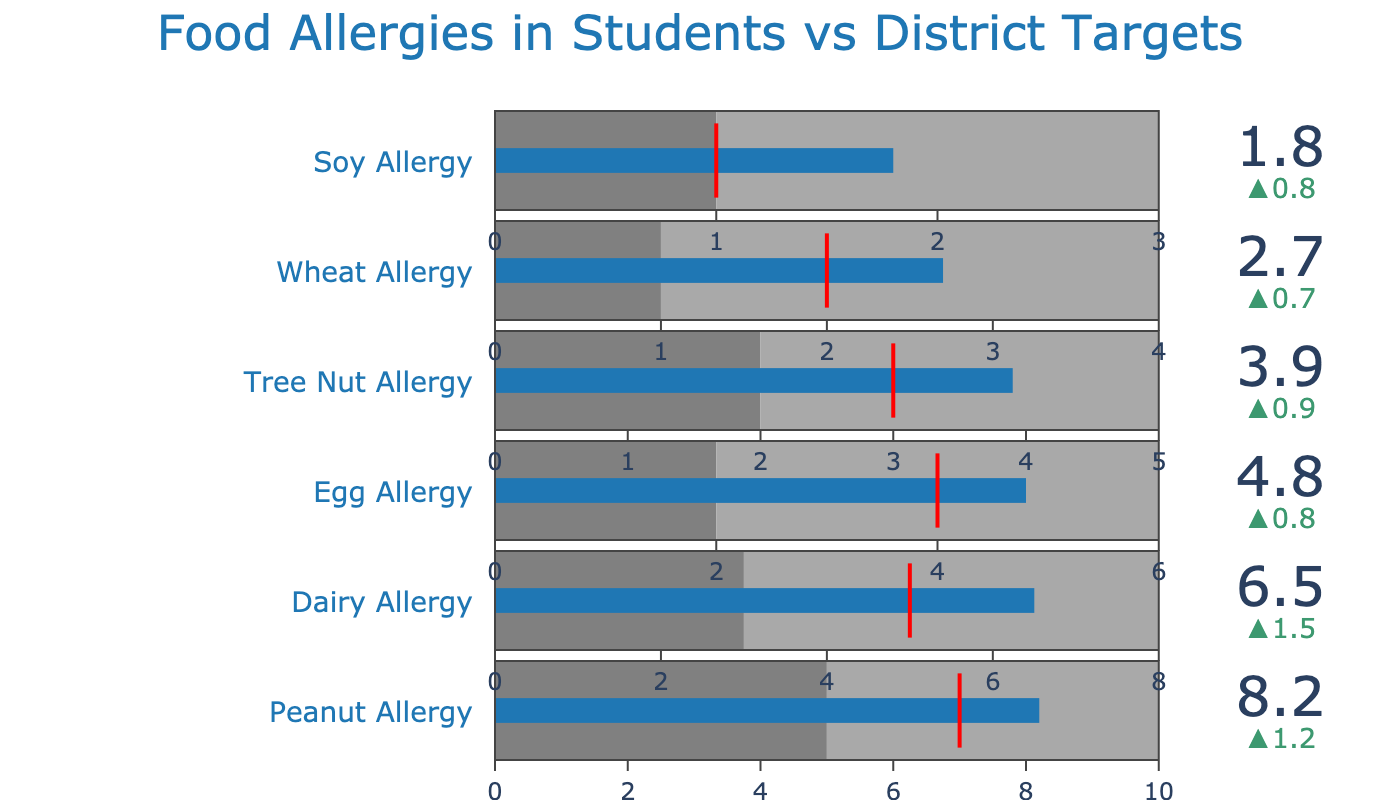What's the actual percentage of students with peanut allergies? The figure displays a bullet chart with the actual percentage, delta, and targets for different food allergies. For peanut allergies, the actual percentage is displayed as 8.2%.
Answer: 8.2% What is the school district target for dairy allergies? The bullet chart specifies targets for various food allergies, and for dairy allergies, the target percentage is indicated as 5%.
Answer: 5% Which food allergy has the largest actual percentage value? By comparing the values displayed on the bullet chart, we can see that the peanut allergy has the largest actual percentage value, which is 8.2%.
Answer: Peanut Allergy How much does the actual percentage of soy allergies differ from the target percentage? The bullet chart shows that the actual percentage for soy allergies is 1.8% and the target is 1%. The difference can be calculated by subtracting the target percentage from the actual percentage: 1.8% - 1% = 0.8%.
Answer: 0.8% Are the actual values for tree nut and egg allergies above or below their respective targets? By inspecting the bullet chart, it is seen that the actual values for both tree nut (3.9% vs. 3%) and egg allergies (4.8% vs. 4%) exceed their respective targets.
Answer: Above What's the average target percentage for all listed food allergies? The target percentages are given as 7, 5, 4, 3, 2, and 1 for the allergies. Adding them gives 22, and dividing by the number of allergies (6) yields an average: 22 ÷ 6 = 3.67.
Answer: 3.67 Which food allergy’s actual percentage is closest to its target? Comparing actual and target values for each allergy: Dairy (6.5% vs 5%), Egg (4.8% vs 4%), Tree Nut (3.9% vs 3%), Wheat (2.7% vs 2%), and Soy (1.8% vs 1%). Soy allergy has the smallest difference of 0.8%.
Answer: Soy Allergy What is the difference between the highest and lowest target percentages? The highest target percentage is for Peanut Allergy (7%) and the lowest is for Soy Allergy (1%). Subtracting the lowest from the highest gives: 7% - 1% = 6%.
Answer: 6% What's the percentage increase from the target to the actual value for dairy allergies? The target for dairy allergies is 5% and the actual value is 6.5%. Calculate the increase as: (6.5% - 5%)/5% * 100% = 30%.
Answer: 30% Are any actual percentages within the lowest range (light gray) set for the bullet charts? By examining the ranges and actual values: only Soy Allergy’s actual percentage (1.8%) falls into the lowest (0-1%) range of its chart.
Answer: None 